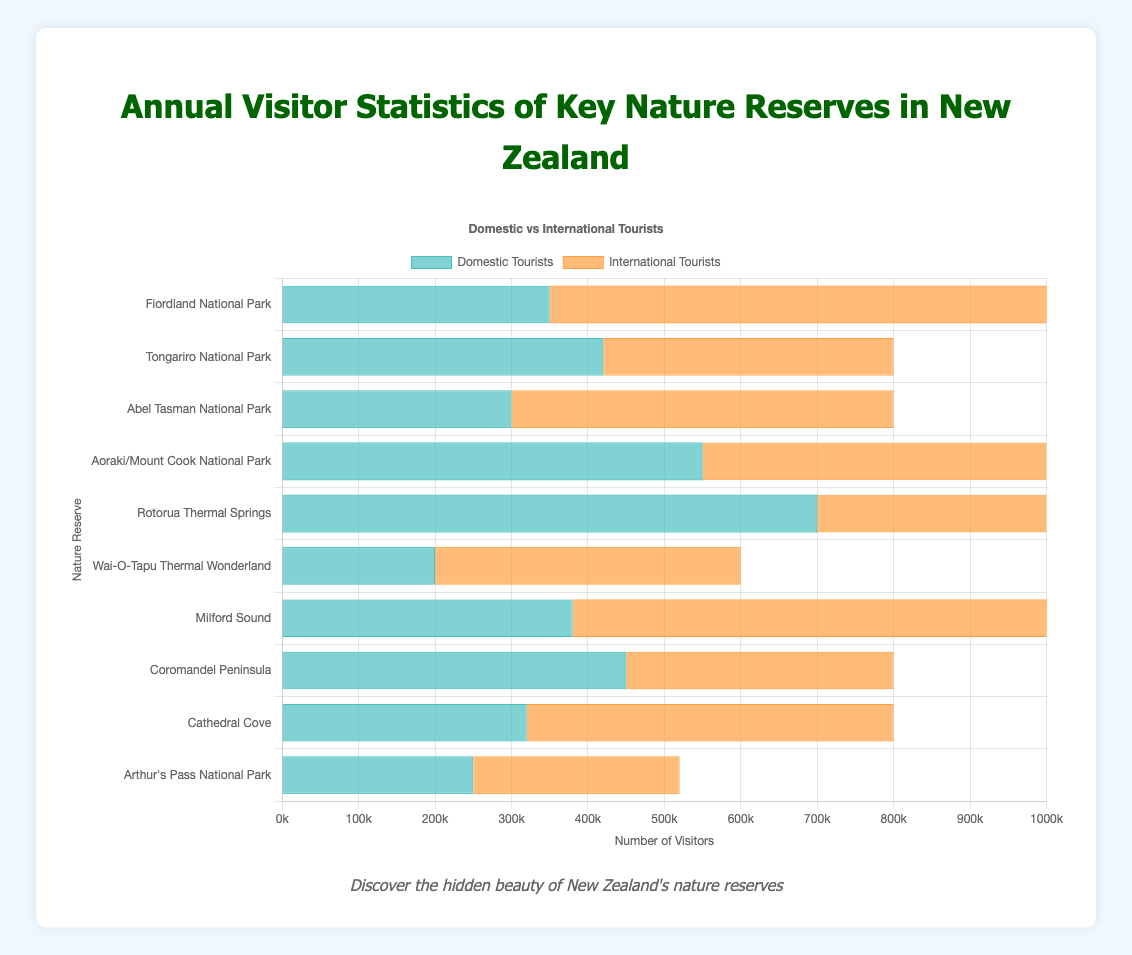What is the most visited nature reserve by international tourists? To determine the most visited nature reserve by international tourists, look for the bar representing international tourists that is longest. Fiordland National Park has the longest bar for international tourists.
Answer: Fiordland National Park Which nature reserve has more domestic tourists than international tourists? Compare the lengths of the domestic and international tourist bars for each nature reserve. Rotorua Thermal Springs has more domestic tourists (700,000) than international tourists (300,000).
Answer: Rotorua Thermal Springs Which nature reserve has the smallest total number of visitors (domestic and international combined)? Sum the domestic and international tourists for each nature reserve and compare the totals. Arthur's Pass National Park has the smallest total number of visitors: (250,000 + 270,000) = 520,000.
Answer: Arthur's Pass National Park How many more domestic tourists does Aoraki/Mount Cook National Park have compared to its international tourists? Subtract the number of international tourists from the number of domestic tourists for Aoraki/Mount Cook National Park. (550,000 - 450,000).
Answer: 100,000 Which nature reserves have equal numbers of domestic and international tourists? Look for nature reserves where the bars for domestic and international tourists are equal in length. There are no nature reserves with equal numbers of domestic and international tourists.
Answer: None Across all nature reserves, what is the average number of domestic tourists? Sum the number of domestic tourists for all nature reserves and divide by the number of nature reserves. (350,000 + 420,000 + 300,000 + 550,000 + 700,000 + 200,000 + 380,000 + 450,000 + 320,000 + 250,000)/10 = 392,000.
Answer: 392,000 For which nature reserves do international tourists outnumber domestic tourists? Compare the international and domestic tourist bars for each nature reserve. Fiordland National Park, Abel Tasman National Park, Milford Sound, and Cathedral Cove have more international tourists.
Answer: Fiordland National Park, Abel Tasman National Park, Milford Sound, Cathedral Cove What is the total number of visitors (domestic and international) to Fiordland National Park? Sum the number of domestic and international tourists for Fiordland National Park. (350,000 + 650,000) = 1,000,000.
Answer: 1,000,000 Arrange the nature reserves in decreasing order of their total visitors (domestic and international combined). Calculate and arrange the sum of domestic and international tourists for each nature reserve in decreasing order. Rotorua Thermal Springs (1,000,000), Fiordland National Park (1,000,000), Milford Sound (1,000,000), Abel Tasman National Park (800,000), Tongariro National Park (800,000), Aoraki/Mount Cook National Park (1,000,000), Cathedral Cove (800,000), Coromandel Peninsula (800,000), Arthur’s Pass National Park (520,000), Wai-O-Tapu Thermal Wonderland (600,000).
Answer: Rotorua Thermal Springs, Fiordland National Park, Milford Sound, Abel Tasman National Park, Tongariro National Park, Aoraki/Mount Cook National Park, Cathedral Cove, Coromandel Peninsula, Arthur's Pass National Park, Wai-O-Tapu Thermal Wonderland 